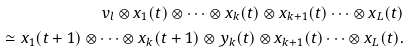Convert formula to latex. <formula><loc_0><loc_0><loc_500><loc_500>v _ { l } \otimes x _ { 1 } ( t ) \otimes \cdots \otimes x _ { k } ( t ) \otimes x _ { k + 1 } ( t ) \cdots \otimes x _ { L } ( t ) \\ \simeq x _ { 1 } ( t + 1 ) \otimes \cdots \otimes x _ { k } ( t + 1 ) \otimes y _ { k } ( t ) \otimes x _ { k + 1 } ( t ) \cdots \otimes x _ { L } ( t ) .</formula> 